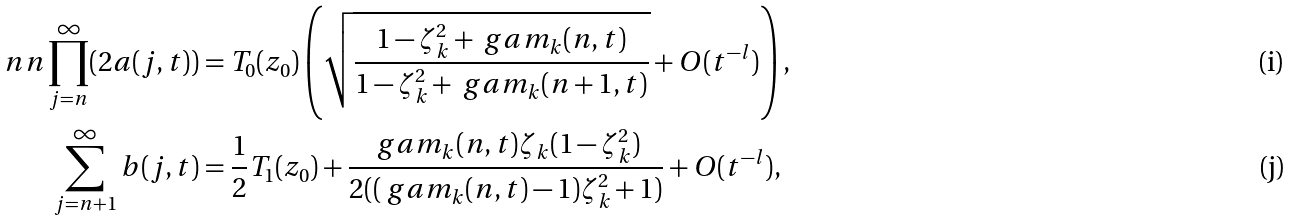Convert formula to latex. <formula><loc_0><loc_0><loc_500><loc_500>\ n n \prod _ { j = n } ^ { \infty } ( 2 a ( j , t ) ) & = T _ { 0 } ( z _ { 0 } ) \left ( \sqrt { \frac { 1 - \zeta _ { k } ^ { 2 } + \ g a m _ { k } ( n , t ) } { 1 - \zeta _ { k } ^ { 2 } + \ g a m _ { k } ( n + 1 , t ) } } + O ( t ^ { - l } ) \right ) , \\ \sum _ { j = n + 1 } ^ { \infty } b ( j , t ) & = \frac { 1 } { 2 } T _ { 1 } ( z _ { 0 } ) + \frac { \ g a m _ { k } ( n , t ) \zeta _ { k } ( 1 - \zeta _ { k } ^ { 2 } ) } { 2 ( ( \ g a m _ { k } ( n , t ) - 1 ) \zeta _ { k } ^ { 2 } + 1 ) } + O ( t ^ { - l } ) ,</formula> 